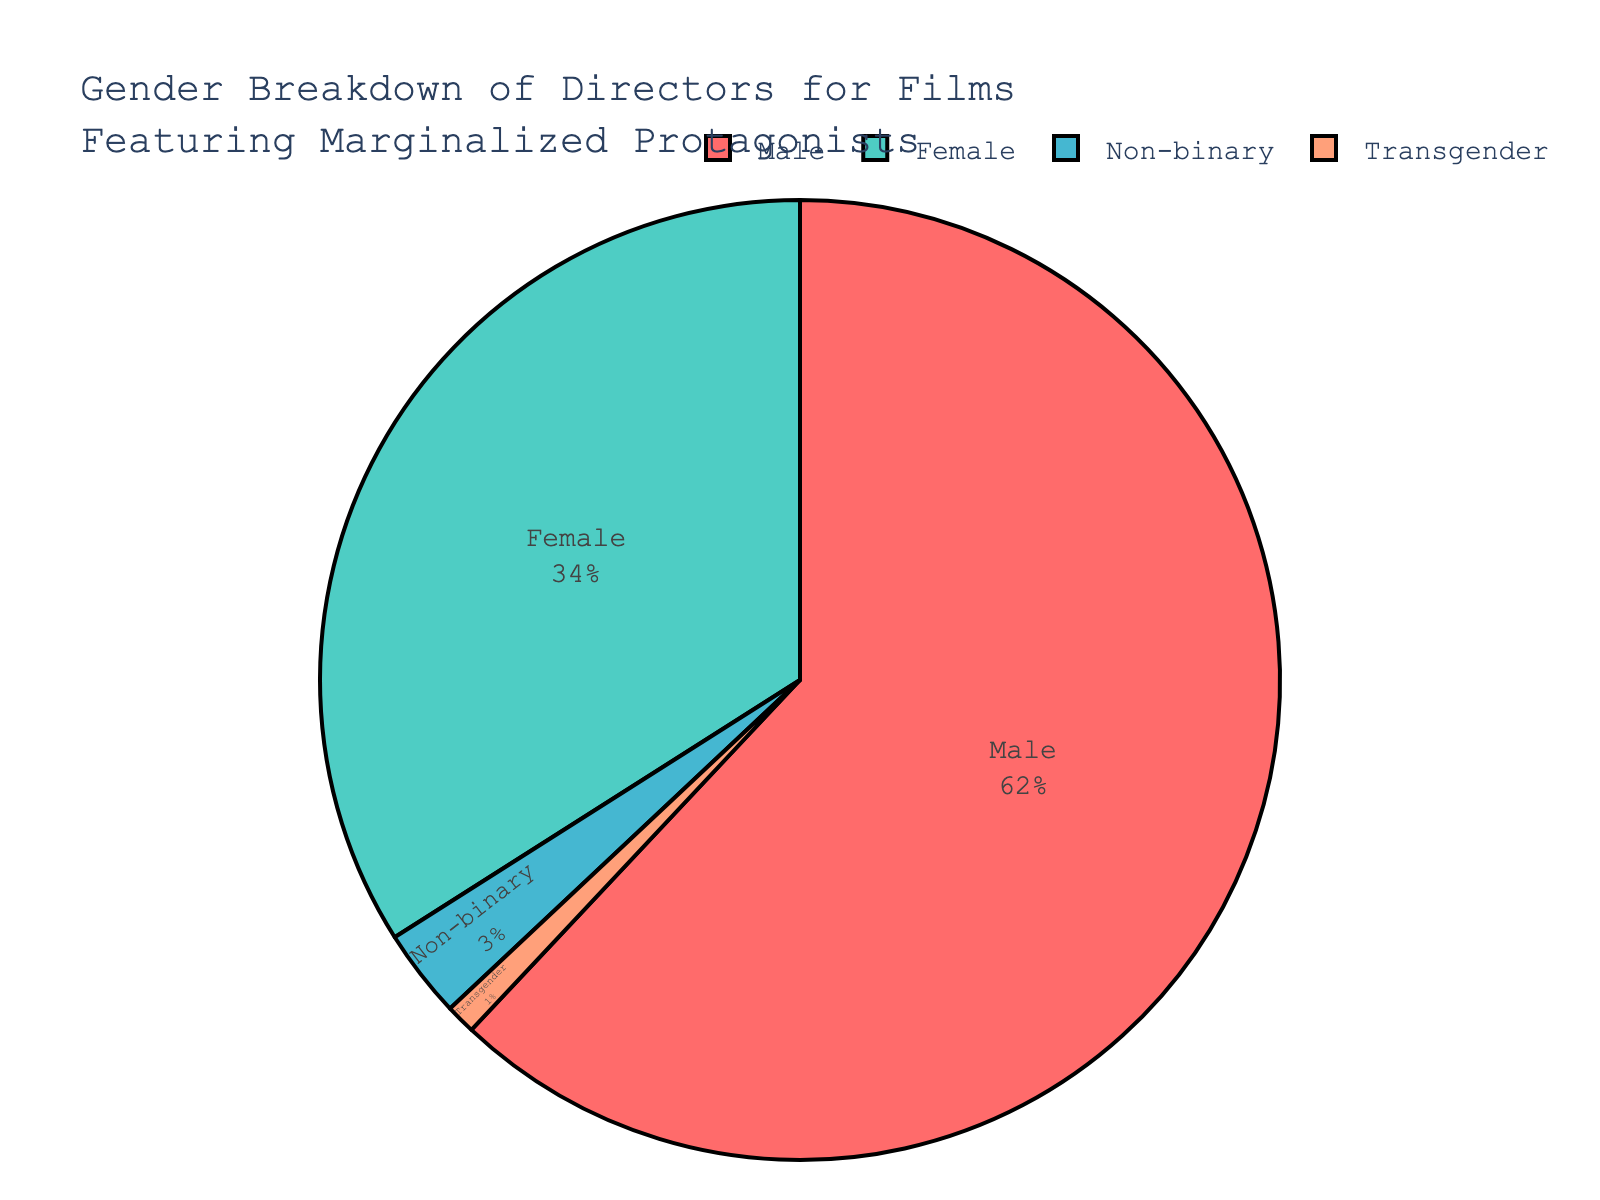What percentage of directors are non-binary? By referring to the figure, we can see that the segment labeled "Non-binary" occupies a portion of the pie chart and is shaded in one of the colors. The percentage of directors listed next to "Non-binary" is 3%.
Answer: 3% Which gender has the highest percentage of directors for films featuring marginalized protagonists? By observing the pie chart, the segment labeled "Male" occupies the largest portion of the chart and hence represents the highest percentage of directors, which is 62%.
Answer: Male How many more percentage points do male directors have compared to female directors? The percentage for male directors is 62%, and for female directors, it is 34%. The difference between these two values is calculated as 62% - 34% = 28%.
Answer: 28% What portion of the pie chart is accounted for by non-binary and transgender directors combined? Combining the percentages for non-binary (3%) and transgender (1%) directors gives us 3% + 1% = 4%.
Answer: 4% How does the percentage of female directors compare to the combined percentage of non-binary and transgender directors? Female directors account for 34%, while non-binary and transgender directors combined account for 4%. To compare, 34% is significantly larger than 4%.
Answer: Female directors have a significantly higher percentage Which gender is represented by the second-largest segment of the pie chart? The second-largest segment after the "Male" segment is labeled "Female," which has 34%.
Answer: Female What is the combined percentage of all directors who are not male? Adding up the percentages for female (34%), non-binary (3%), and transgender (1%) directors results in 34% + 3% + 1% = 38%.
Answer: 38% What does the color assigned to non-binary directors represent in terms of the figure's legend? The pie chart's legend uses specific colors to represent different genders. By finding the color that corresponds to "Non-binary" in the legend, we can determine which part of the chart represents non-binary directors.
Answer: A segment representing 3% 